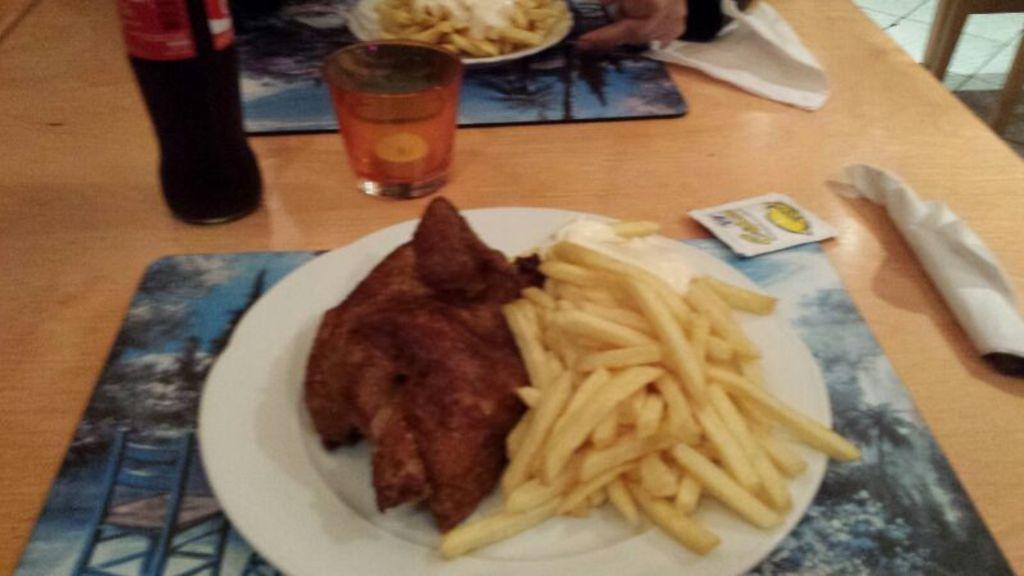How would you summarize this image in a sentence or two? In the image there is a plate with french fries with meat on a wooden table along with soft drink,glass,tissues and another plate with french fries in front of it. 